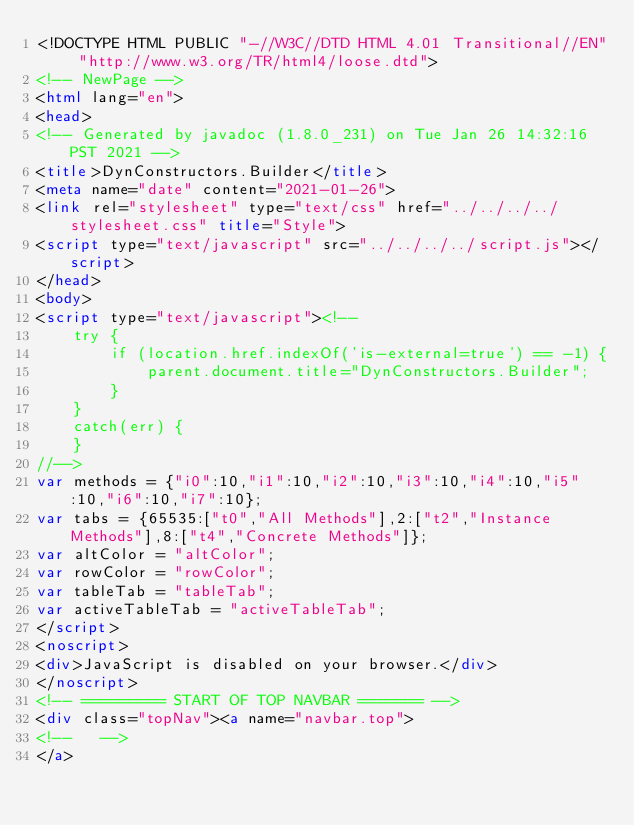<code> <loc_0><loc_0><loc_500><loc_500><_HTML_><!DOCTYPE HTML PUBLIC "-//W3C//DTD HTML 4.01 Transitional//EN" "http://www.w3.org/TR/html4/loose.dtd">
<!-- NewPage -->
<html lang="en">
<head>
<!-- Generated by javadoc (1.8.0_231) on Tue Jan 26 14:32:16 PST 2021 -->
<title>DynConstructors.Builder</title>
<meta name="date" content="2021-01-26">
<link rel="stylesheet" type="text/css" href="../../../../stylesheet.css" title="Style">
<script type="text/javascript" src="../../../../script.js"></script>
</head>
<body>
<script type="text/javascript"><!--
    try {
        if (location.href.indexOf('is-external=true') == -1) {
            parent.document.title="DynConstructors.Builder";
        }
    }
    catch(err) {
    }
//-->
var methods = {"i0":10,"i1":10,"i2":10,"i3":10,"i4":10,"i5":10,"i6":10,"i7":10};
var tabs = {65535:["t0","All Methods"],2:["t2","Instance Methods"],8:["t4","Concrete Methods"]};
var altColor = "altColor";
var rowColor = "rowColor";
var tableTab = "tableTab";
var activeTableTab = "activeTableTab";
</script>
<noscript>
<div>JavaScript is disabled on your browser.</div>
</noscript>
<!-- ========= START OF TOP NAVBAR ======= -->
<div class="topNav"><a name="navbar.top">
<!--   -->
</a></code> 